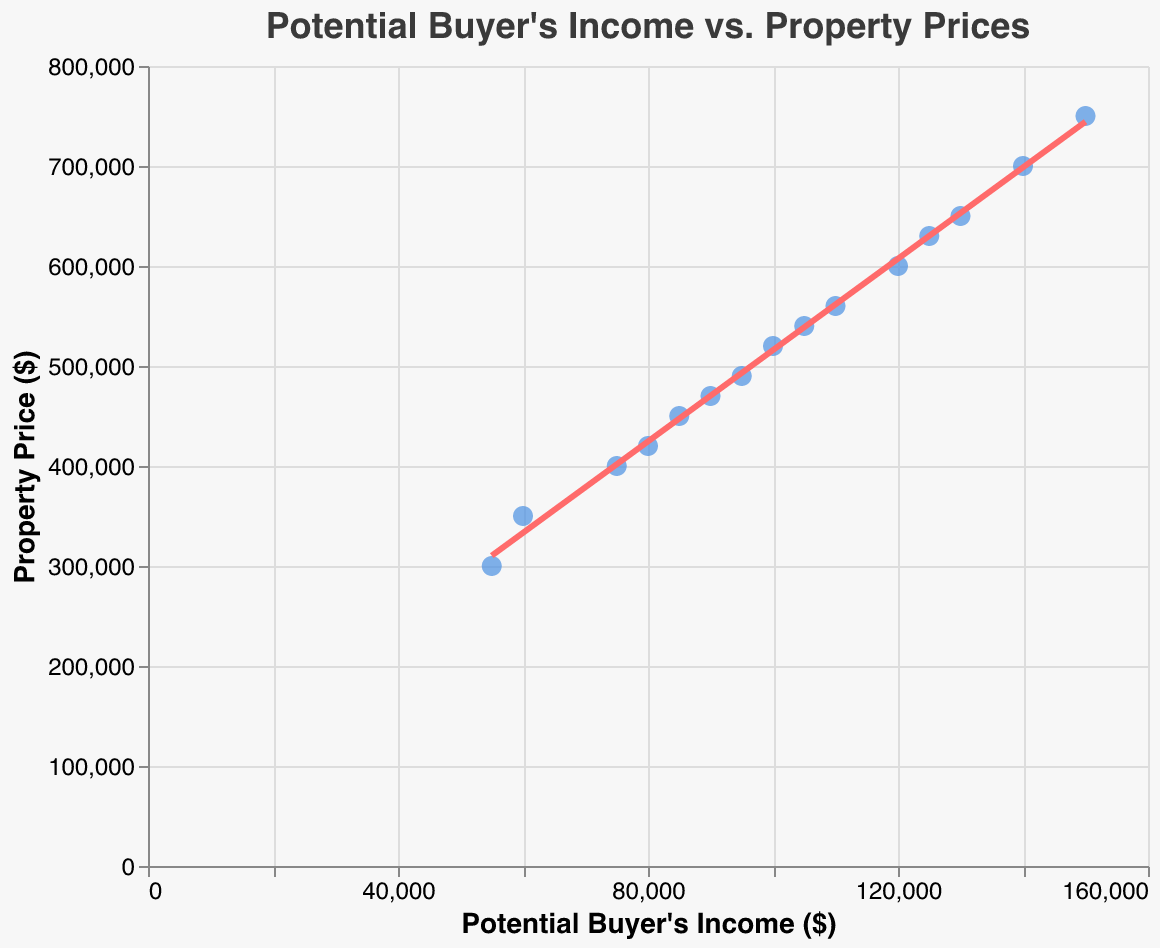What is the title of the plot? The title is located at the top of the figure. It reads "Potential Buyer's Income vs. Property Prices."
Answer: Potential Buyer's Income vs. Property Prices How many data points are plotted in the scatter plot? Count the number of points on the scatter plot. There are 15 data points representing different income and property price pairs.
Answer: 15 What is the trend shown by the trend line? The trend line shows the direction of the relationship between income and property prices. It is upward-sloping, indicating a positive relationship.
Answer: Positive What is the property price for an income of $75,000? Locate the data point directly above the $75,000 income mark on the x-axis and read the corresponding property price on the y-axis.
Answer: $400,000 Is the property price for an income of $90,000 less than or greater than $500,000? Find the data point for $90,000 income on the x-axis and check the corresponding property price on the y-axis. It is less than $500,000.
Answer: Less than $500,000 What is the range of property prices shown in the plot? Identify the minimum and maximum property prices from the plotted data points. The range is from $300,000 to $750,000.
Answer: $300,000 to $750,000 What income is associated with the highest property price? Locate the highest point on the y-axis and find the corresponding income on the x-axis. The highest property price is $750,000 associated with an income of $150,000.
Answer: $150,000 What is the average property price for incomes above $100,000? Identify the property prices for incomes above $100,000: $540,000, $560,000, $600,000, $630,000, $650,000, $700,000, $750,000. Sum these prices and divide by the number of points (7). Average = ($540,000+$560,000+$600,000+$630,000+$650,000+$700,000+$750,000) / 7 = $ 633,571
Answer: $633,571 For an income of $100,000, is the trend line above or below the actual data point? Look at the point where income is $100,000 and compare its vertical position with the trend line. The actual data point is slightly above the trend line.
Answer: Above 